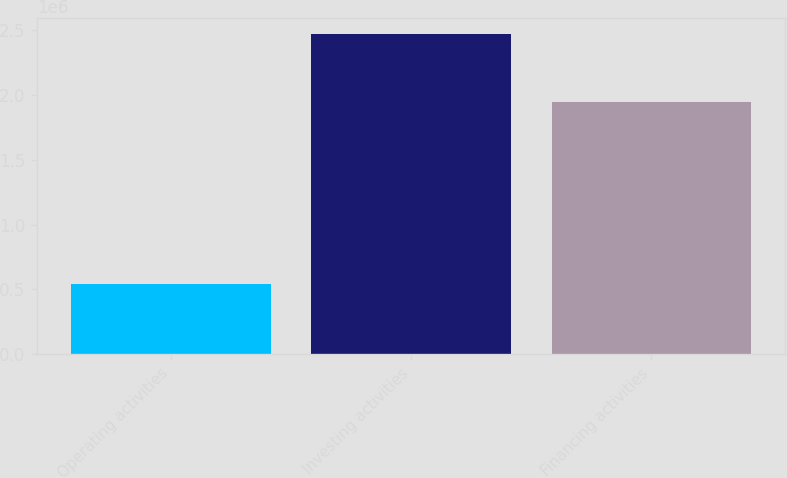<chart> <loc_0><loc_0><loc_500><loc_500><bar_chart><fcel>Operating activities<fcel>Investing activities<fcel>Financing activities<nl><fcel>542948<fcel>2.47593e+06<fcel>1.94864e+06<nl></chart> 